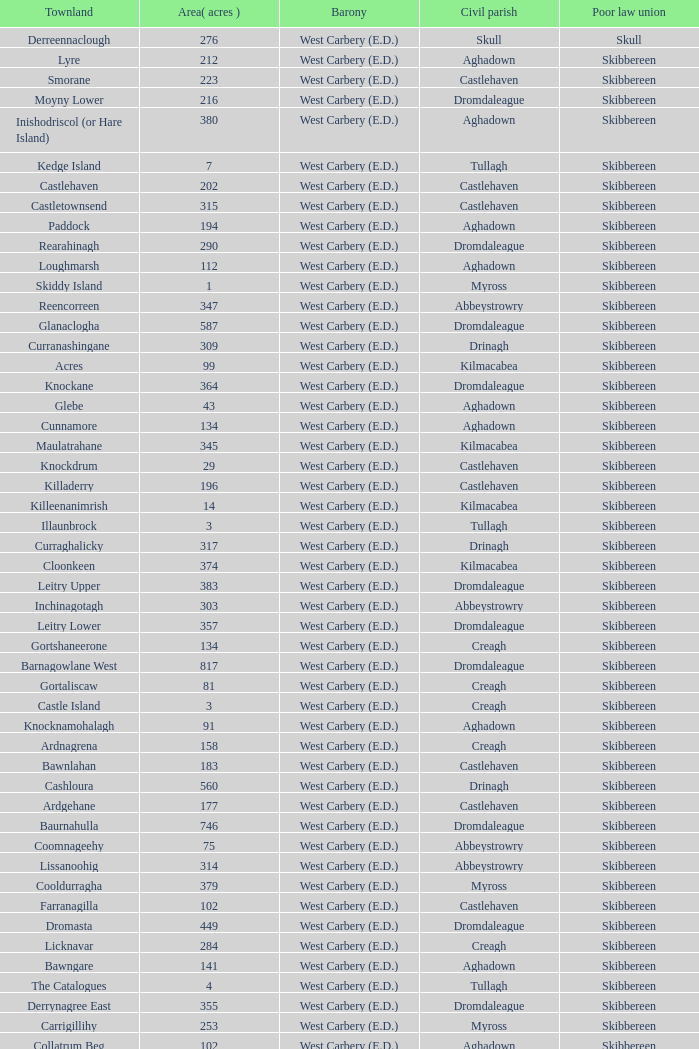What are the Poor Law Unions when the area (in acres) is 142? Skibbereen. 